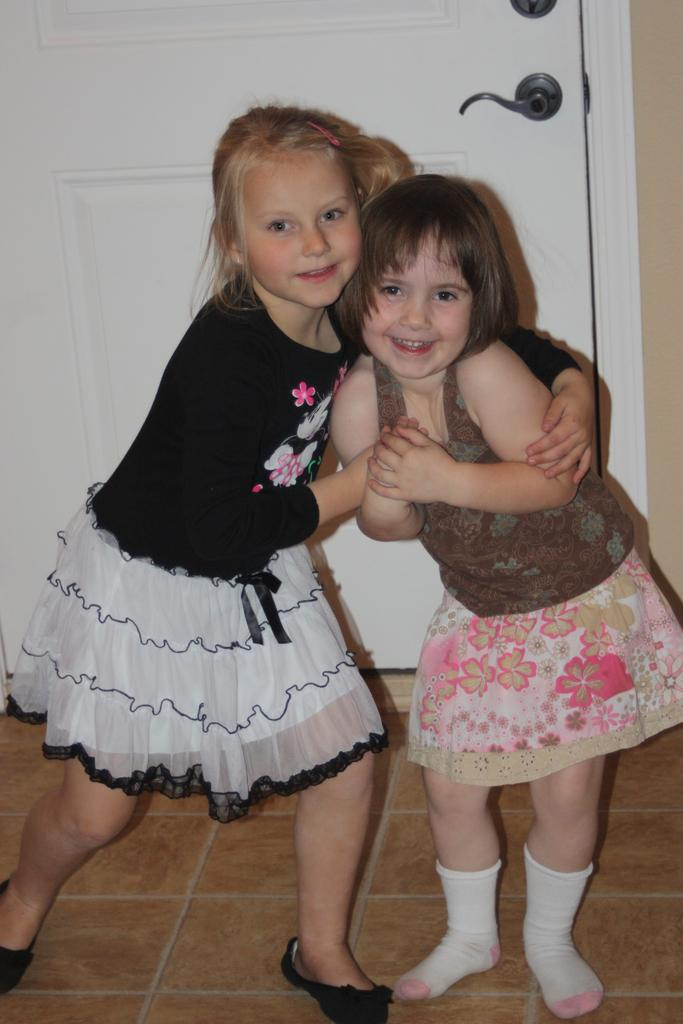Who is in the front of the image? There are girls standing in the front of the image. What are the girls doing in the image? The girls are smiling. What can be seen in the background of the image? There is a door in the background of the image. What is the color of the door? The door is white in color. What type of scissors can be seen on the table in the image? There is no table or scissors present in the image. What book is the girl reading in the image? There is no book or girl reading in the image. 